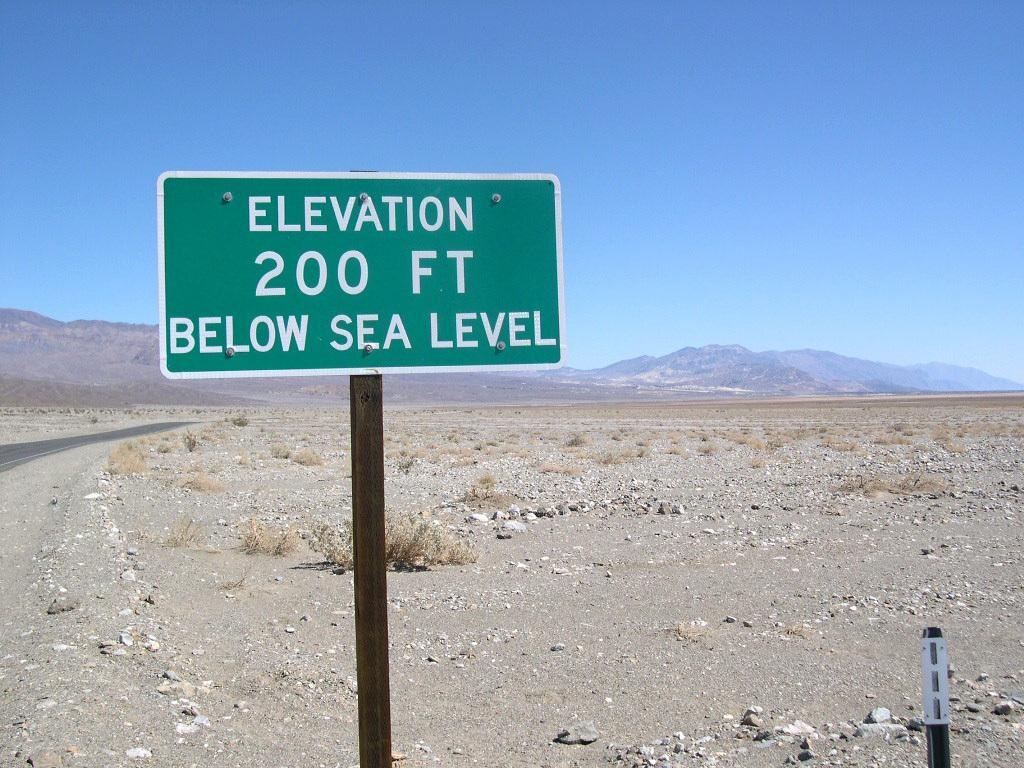<image>
Write a terse but informative summary of the picture. Green and white sign on a road which says elevation is 200 ft below sea level. 